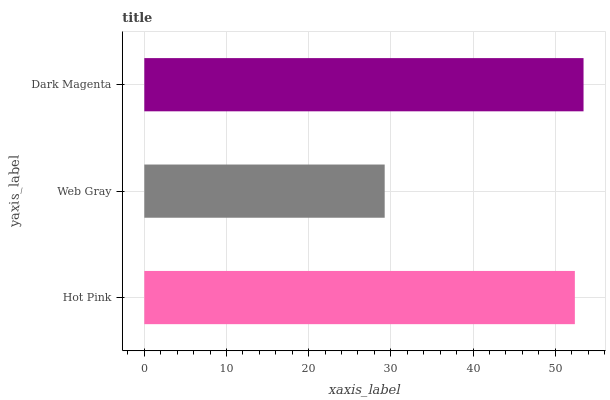Is Web Gray the minimum?
Answer yes or no. Yes. Is Dark Magenta the maximum?
Answer yes or no. Yes. Is Dark Magenta the minimum?
Answer yes or no. No. Is Web Gray the maximum?
Answer yes or no. No. Is Dark Magenta greater than Web Gray?
Answer yes or no. Yes. Is Web Gray less than Dark Magenta?
Answer yes or no. Yes. Is Web Gray greater than Dark Magenta?
Answer yes or no. No. Is Dark Magenta less than Web Gray?
Answer yes or no. No. Is Hot Pink the high median?
Answer yes or no. Yes. Is Hot Pink the low median?
Answer yes or no. Yes. Is Dark Magenta the high median?
Answer yes or no. No. Is Web Gray the low median?
Answer yes or no. No. 